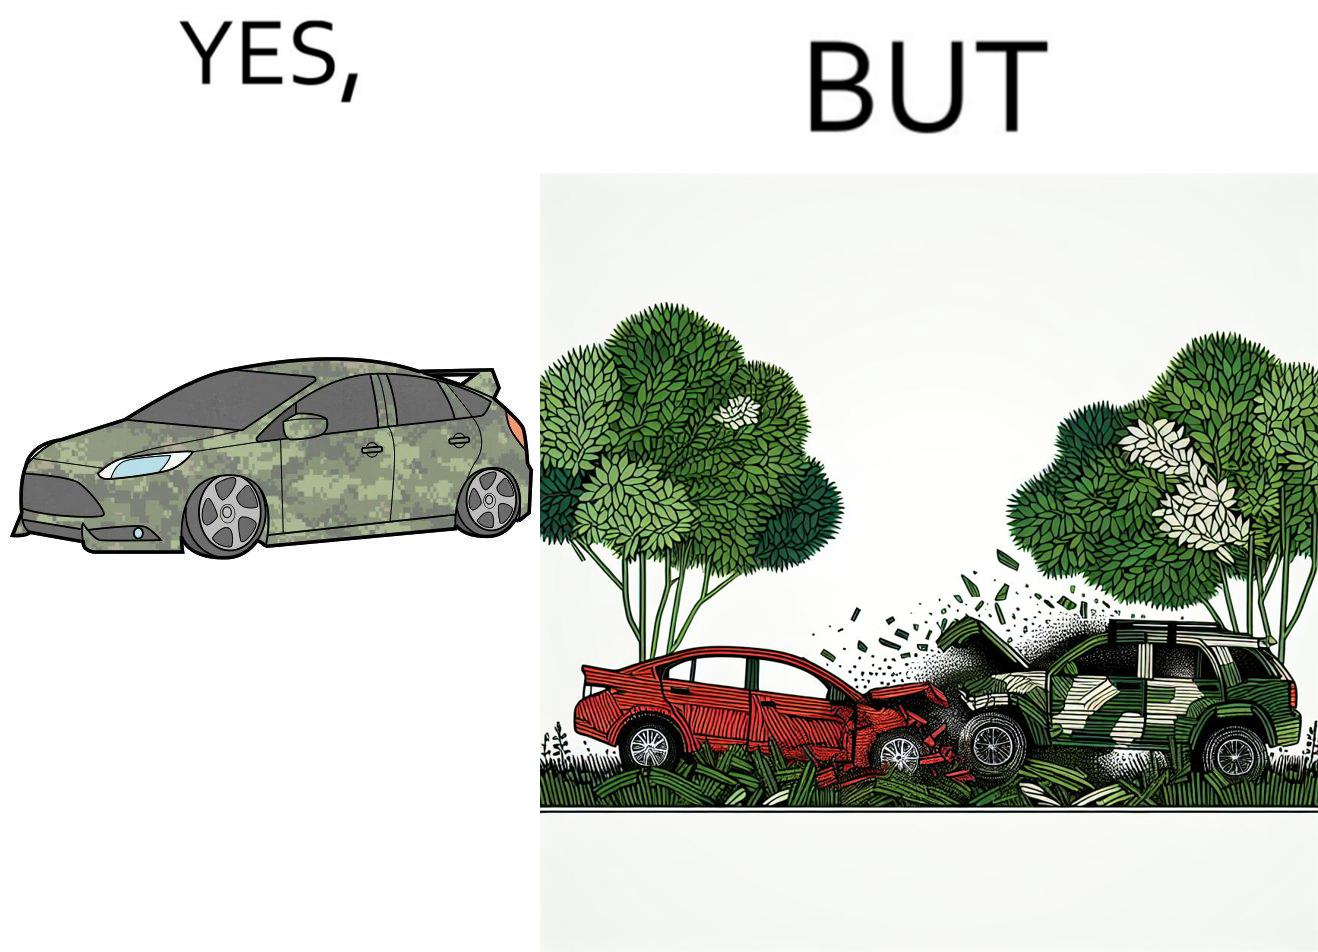What is shown in this image? The image is ironic, because in the left image a car is painted in camouflage color but in the right image the same car is getting involved in accident to due to its color as other drivers face difficulty in recognizing the colors 